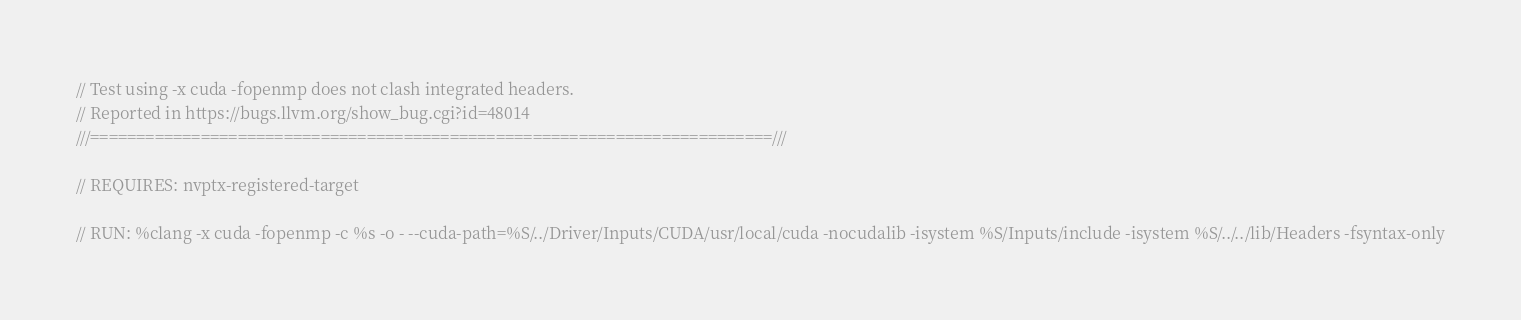<code> <loc_0><loc_0><loc_500><loc_500><_Cuda_>// Test using -x cuda -fopenmp does not clash integrated headers.
// Reported in https://bugs.llvm.org/show_bug.cgi?id=48014
///==========================================================================///

// REQUIRES: nvptx-registered-target

// RUN: %clang -x cuda -fopenmp -c %s -o - --cuda-path=%S/../Driver/Inputs/CUDA/usr/local/cuda -nocudalib -isystem %S/Inputs/include -isystem %S/../../lib/Headers -fsyntax-only

</code> 